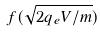<formula> <loc_0><loc_0><loc_500><loc_500>f ( \sqrt { 2 q _ { e } V / m } )</formula> 